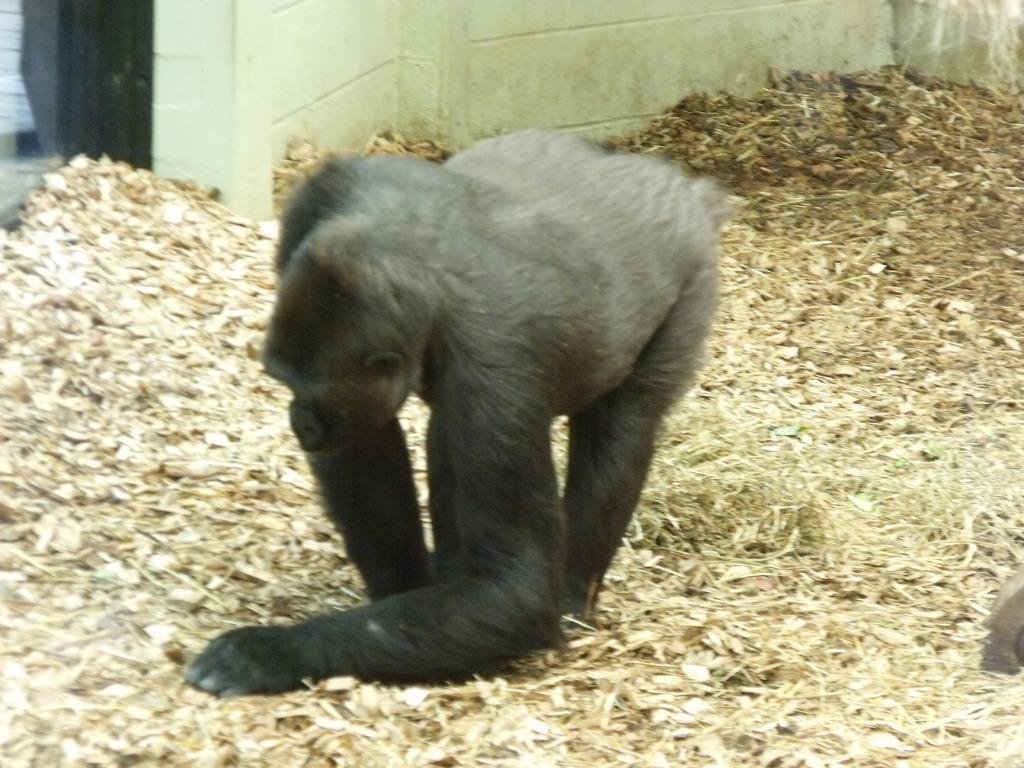What animal is present in the image? There is a gorilla in the image. What is the gorilla doing in the image? The gorilla is walking on the ground in the image. What can be seen in the background of the image? There is a wall in the background of the image. What type of orange is the dog holding in the image? There is no dog or orange present in the image; it features a gorilla walking on the ground. Can you tell me how many bats are flying in the image? There are no bats present in the image; it only features a gorilla walking on the ground and a wall in the background. 